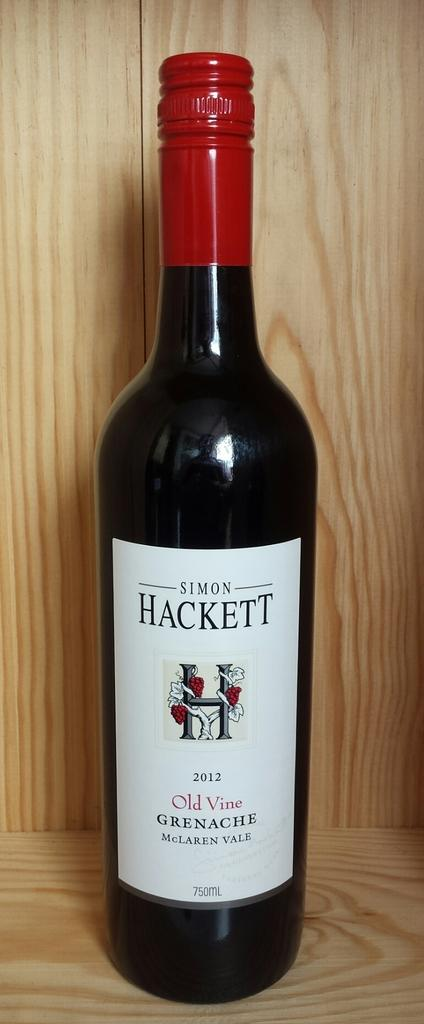<image>
Offer a succinct explanation of the picture presented. an image of a wine bottle with the name 'Simon Hackett' on it. 